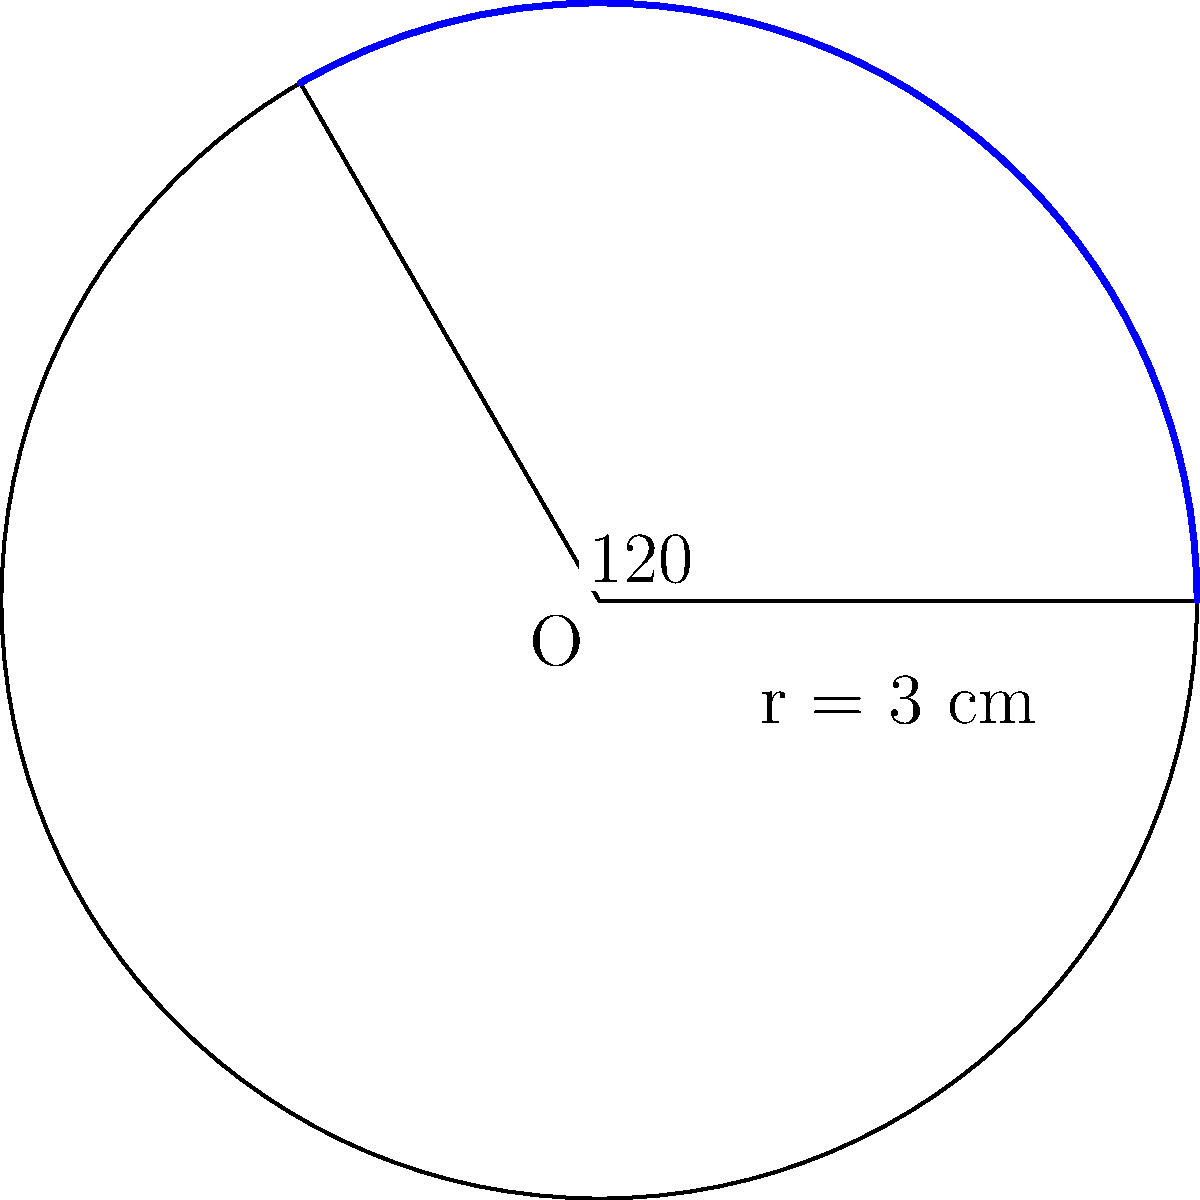Your grandchild is learning about circular sectors in geometry class. To help them understand the concept better, you decide to create a practical problem. A circular garden bed has a radius of 3 cm. If you want to plant flowers in a sector of the garden that spans a central angle of 120°, what is the area of this planting sector? Round your answer to two decimal places. Let's approach this step-by-step:

1) The formula for the area of a circular sector is:
   $$A = \frac{\theta}{360°} \pi r^2$$
   Where $\theta$ is the central angle in degrees, and $r$ is the radius.

2) We're given:
   - Radius (r) = 3 cm
   - Central angle ($\theta$) = 120°

3) Let's substitute these values into our formula:
   $$A = \frac{120°}{360°} \pi (3\text{ cm})^2$$

4) Simplify:
   $$A = \frac{1}{3} \pi (9\text{ cm}^2)$$
   $$A = 3\pi\text{ cm}^2$$

5) Calculate:
   $$A \approx 3 \times 3.14159 \text{ cm}^2 = 9.42477\text{ cm}^2$$

6) Rounding to two decimal places:
   $$A \approx 9.42\text{ cm}^2$$
Answer: $9.42\text{ cm}^2$ 